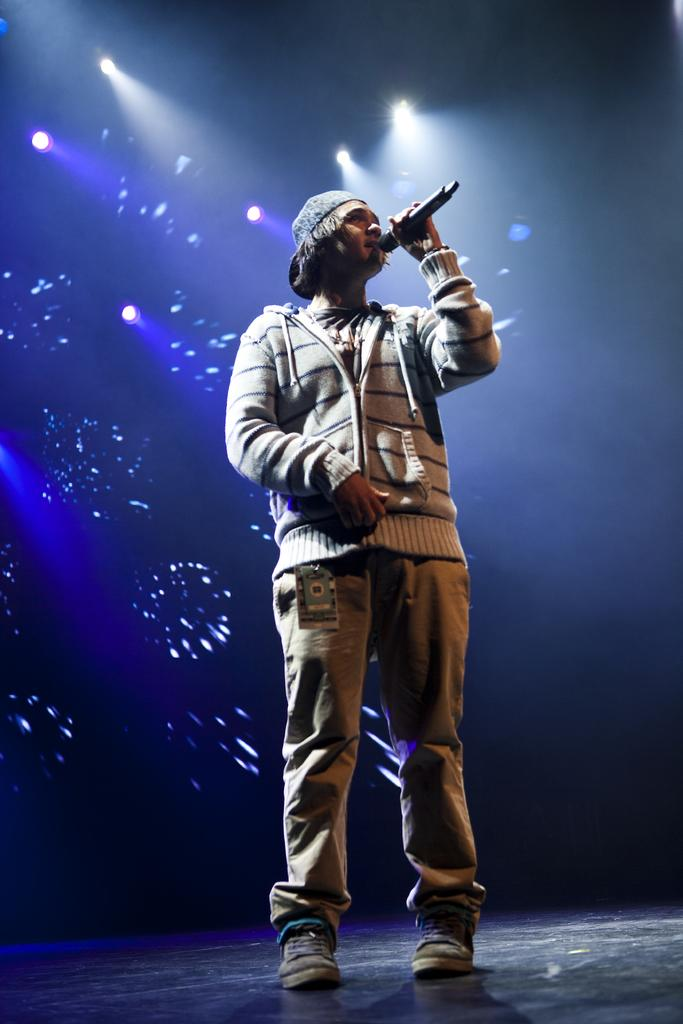What is the man in the image doing? The man is singing in the image. What is the man holding while singing? The man is holding a microphone. Can you describe any identifying features of the man? The man is wearing a tag. What is visible beneath the man's feet in the image? There is a floor visible in the image. What can be seen in the background of the image? There are lights and a screen in the background of the image. What type of flag is being waved by the man in the image? There is no flag present in the image; the man is holding a microphone. Can you see a truck in the image? There is no truck present in the image. 